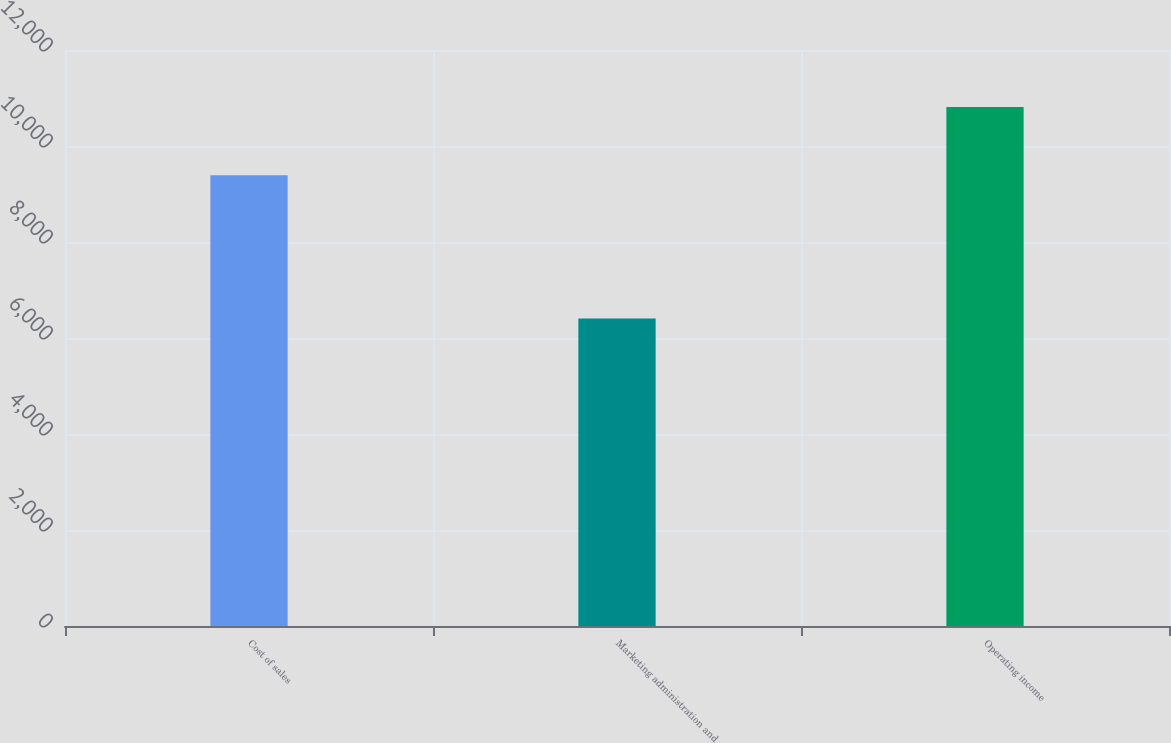<chart> <loc_0><loc_0><loc_500><loc_500><bar_chart><fcel>Cost of sales<fcel>Marketing administration and<fcel>Operating income<nl><fcel>9391<fcel>6405<fcel>10815<nl></chart> 